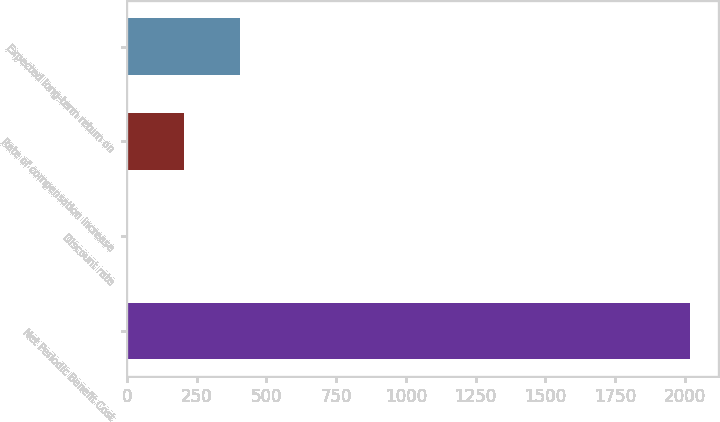Convert chart. <chart><loc_0><loc_0><loc_500><loc_500><bar_chart><fcel>Net Periodic Benefit Cost<fcel>Discount rate<fcel>Rate of compensation increase<fcel>Expected long-term return on<nl><fcel>2019<fcel>1.69<fcel>203.42<fcel>405.15<nl></chart> 